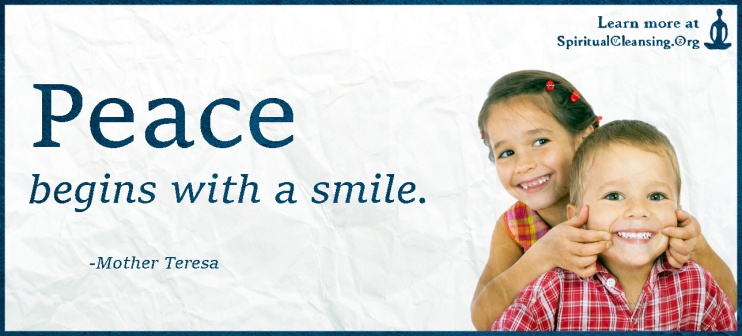Analyze the image in a comprehensive and detailed manner.
 The image presents a heartwarming scene captured on a blue banner. At the center of the banner, two children, a girl and a boy, are the main focus. They are both smiling brightly, their joy palpable even in the still image. The girl, dressed in a pink shirt, and the boy, in a blue one, are making peace signs with their hands, a universal symbol of harmony and goodwill.

The quote "Peace begins with a smile." attributed to Mother Teresa is prominently displayed on the banner, reinforcing the message conveyed by the children's actions. The quote, along with the website "SpiritualCleansing.org", is written in white, contrasting sharply with the light blue background, ensuring it catches the viewer's attention.

The background itself is a subtle texture of light blue, providing a calming backdrop to the vibrant scene. The overall composition of the image, with its central focus on the children and the surrounding text, creates a harmonious balance between the elements, effectively conveying its message of peace and positivity. 